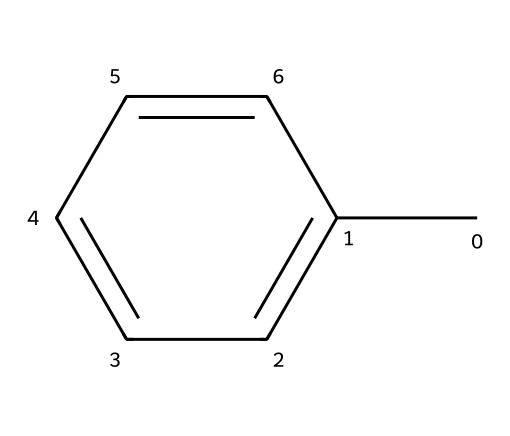What is the molecular formula of toluene? The molecular formula is derived from the counts of carbon (C) and hydrogen (H) atoms in the structure. The SMILES notation indicates 7 carbon atoms (indicated by 'C' and 'c') and 8 hydrogen atoms surrounding them. Thus, the molecular formula is C7H8.
Answer: C7H8 How many carbon atoms are in toluene? By examining the SMILES representation, there are 7 instances of 'C' which represent the carbon atoms in the molecule.
Answer: 7 What type of chemical structure does toluene have? The structure consists of a benzene ring as indicated by the alternating single and double bonds in the aromatic system. Toluene is derived from benzene with a methyl group attached, making it an aromatic hydrocarbon.
Answer: aromatic hydrocarbon Is toluene polar or non-polar? Toluene has a non-polar nature because its aromatic hydrocarbon structure does not have significant electronegative atoms or functional groups that create polarity, and the symmetrical distribution of electrons contributes to its non-polar character.
Answer: non-polar What is the primary use of toluene in printing inks? Toluene is primarily used as a solvent in printing inks due to its ability to dissolve a wide range of substances, including resins and pigments, facilitating the formulation of ink for application.
Answer: solvent Which functional group is present in toluene? Toluene contains a methyl group (-CH3) attached to a benzene ring. This group is crucial for defining its properties and reactivity.
Answer: methyl group What is the boiling point range of toluene? The boiling point of toluene is approximately 110°C, which is a typical property of solvents used in various applications including printing inks.
Answer: 110°C 